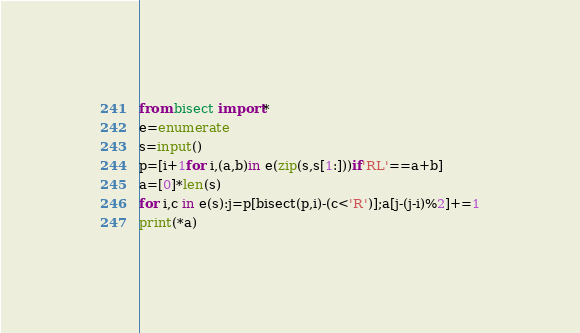<code> <loc_0><loc_0><loc_500><loc_500><_Python_>from bisect import*
e=enumerate
s=input()
p=[i+1for i,(a,b)in e(zip(s,s[1:]))if'RL'==a+b]
a=[0]*len(s)
for i,c in e(s):j=p[bisect(p,i)-(c<'R')];a[j-(j-i)%2]+=1
print(*a)</code> 